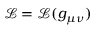Convert formula to latex. <formula><loc_0><loc_0><loc_500><loc_500>{ \mathcal { L } } = { \mathcal { L } } ( g _ { \mu \nu } )</formula> 